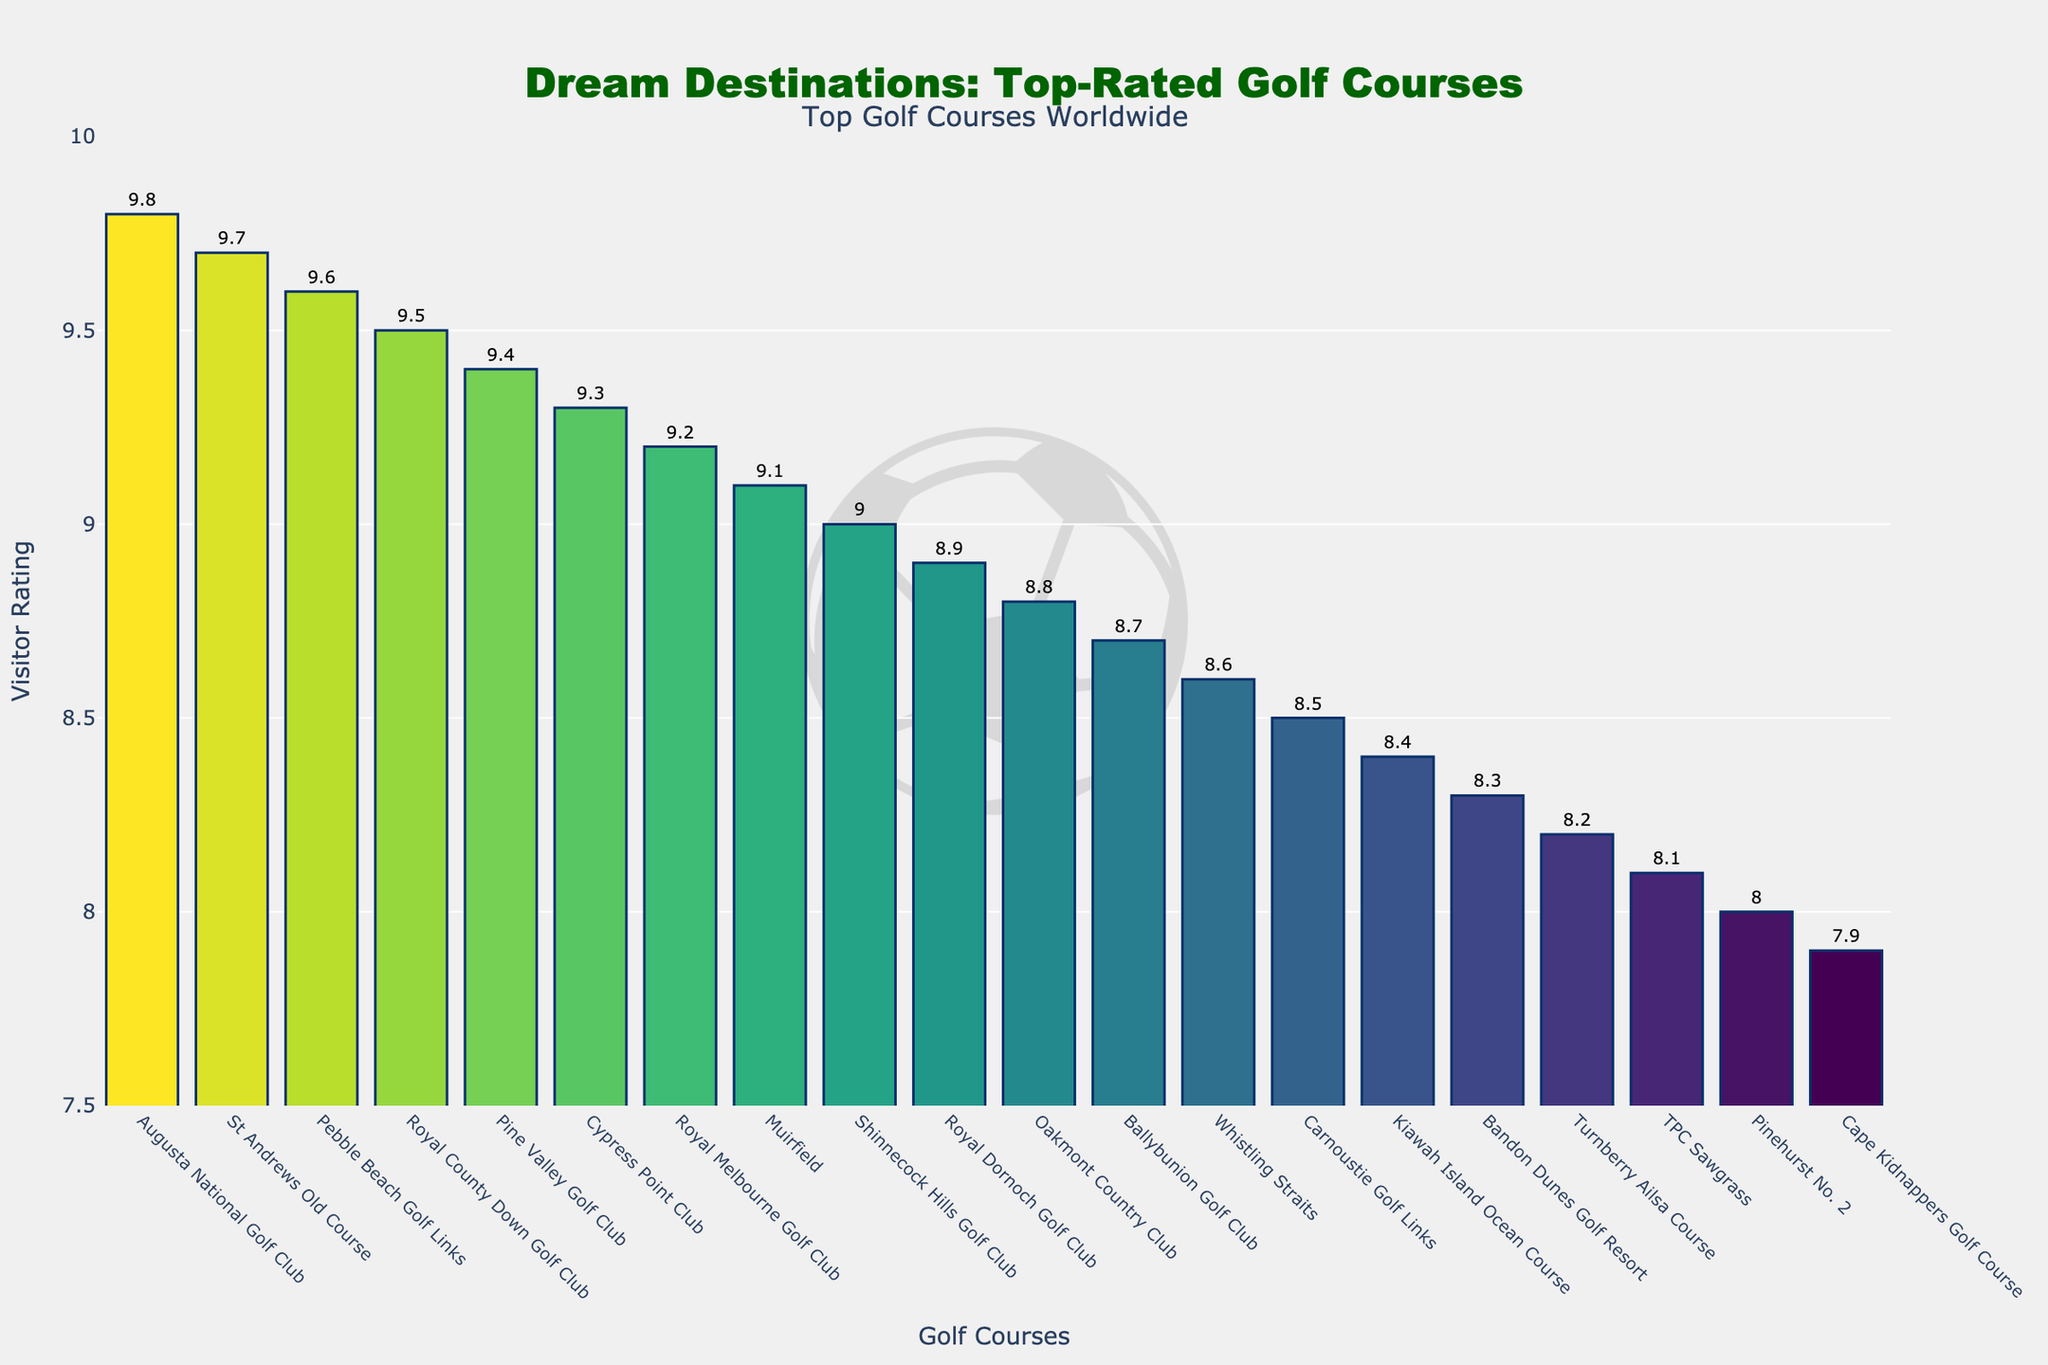Which golf course has the highest visitor rating? Augusta National Golf Club has the highest visitor rating with a rating of 9.8. This can be determined by observing the bar chart where Augusta National Golf Club's bar is the tallest and has the highest numerical value displayed.
Answer: Augusta National Golf Club How many golf courses have a visitor rating of 9.0 and above? To find the number of courses with ratings of 9.0 and above, count the bars that have a rating of 9.0 or higher. These courses are Augusta National Golf Club (9.8), St Andrews Old Course (9.7), Pebble Beach Golf Links (9.6), Royal County Down Golf Club (9.5), Pine Valley Golf Club (9.4), Cypress Point Club (9.3), Royal Melbourne Golf Club (9.2), and Muirfield (9.1).
Answer: 8 Which course has a higher visitor rating, St Andrews Old Course or Oakmont Country Club? Compare the ratings of St Andrews Old Course and Oakmont Country Club. St Andrews Old Course has a rating of 9.7, while Oakmont Country Club has a rating of 8.8.
Answer: St Andrews Old Course What is the difference in visitor rating between Pebble Beach Golf Links and Royal Dornoch Golf Club? Calculate the difference in rating by subtracting the rating of Royal Dornoch Golf Club (8.9) from that of Pebble Beach Golf Links (9.6). The calculation is 9.6 - 8.9.
Answer: 0.7 Which golf course has the lowest visitor rating among the top-rated courses? By observing the chart, the course with the smallest bar among the displayed top courses (ratings starting from 9.8 to 8.9) is Royal Dornoch Golf Club with a rating of 8.9.
Answer: Royal Dornoch Golf Club How many courses have a rating between 9.1 and 9.5 inclusive? Observe the bars that fall within the rating range of 9.1 to 9.5. These courses are Royal County Down Golf Club (9.5), Pine Valley Golf Club (9.4), Cypress Point Club (9.3), Royal Melbourne Golf Club (9.2), and Muirfield (9.1).
Answer: 5 What is the median visitor rating of the top 10 golf courses? To find the median value of the top 10 ratings, list them in ascending order: 8.9, 9.0, 9.1, 9.2, 9.3, 9.4, 9.5, 9.6, 9.7, 9.8. The median is the average of the 5th and 6th values, which are 9.3 and 9.4. (9.3 + 9.4) / 2 = 9.35.
Answer: 9.35 Visual observation: Which bar has the darkest color? The color intensity corresponds to the rating value. The darkest color should be the bar with the highest rating, which is Augusta National Golf Club with a rating of 9.8.
Answer: Augusta National Golf Club 